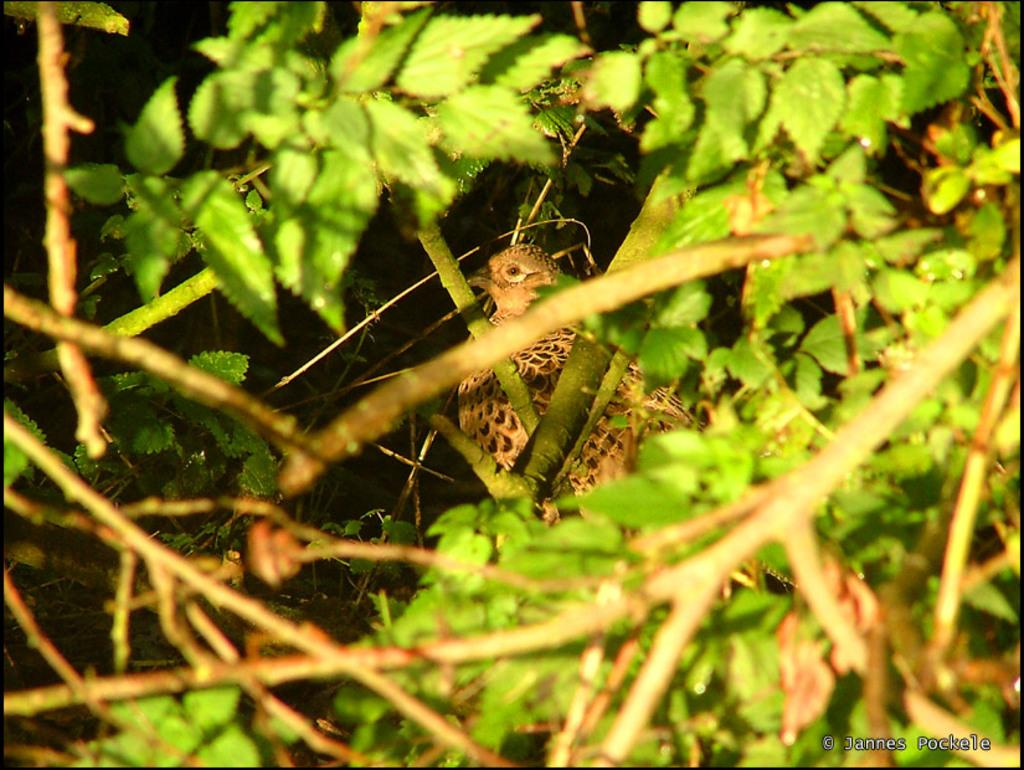What type of vegetation is present in the image? There are green color leaves in the image. What part of the plant can be seen in the image? There are stems in the image. What animal can be seen in the background of the image? There is a bird visible in the background of the image. Where is the watermark located in the image? The watermark is on the bottom right side of the image. How does the bread jump in the image? There is no bread present in the image, so it cannot jump. 